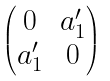<formula> <loc_0><loc_0><loc_500><loc_500>\begin{pmatrix} 0 & a _ { 1 } ^ { \prime } \\ a _ { 1 } ^ { \prime } & 0 \end{pmatrix}</formula> 